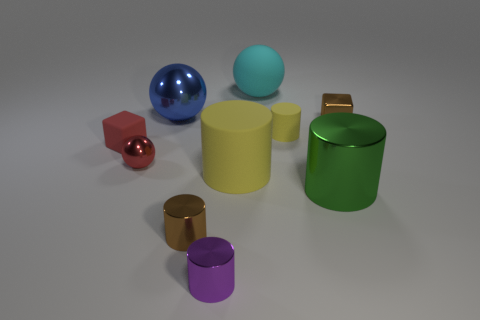What is the material of the thing that is the same color as the large rubber cylinder?
Make the answer very short. Rubber. How many cylinders are green metal objects or small brown objects?
Offer a terse response. 2. What is the color of the ball that is the same size as the shiny block?
Give a very brief answer. Red. The tiny rubber thing that is the same shape as the tiny purple metallic thing is what color?
Keep it short and to the point. Yellow. How many objects are either large green metal objects or balls in front of the blue shiny thing?
Offer a very short reply. 2. Are there fewer tiny spheres behind the red block than large brown cubes?
Keep it short and to the point. No. There is a yellow cylinder that is in front of the tiny rubber object on the left side of the small purple cylinder that is in front of the small red cube; what is its size?
Offer a very short reply. Large. What is the color of the large thing that is in front of the blue sphere and to the left of the small yellow rubber thing?
Offer a terse response. Yellow. What number of yellow cylinders are there?
Your response must be concise. 2. Is the blue object made of the same material as the brown cylinder?
Ensure brevity in your answer.  Yes. 